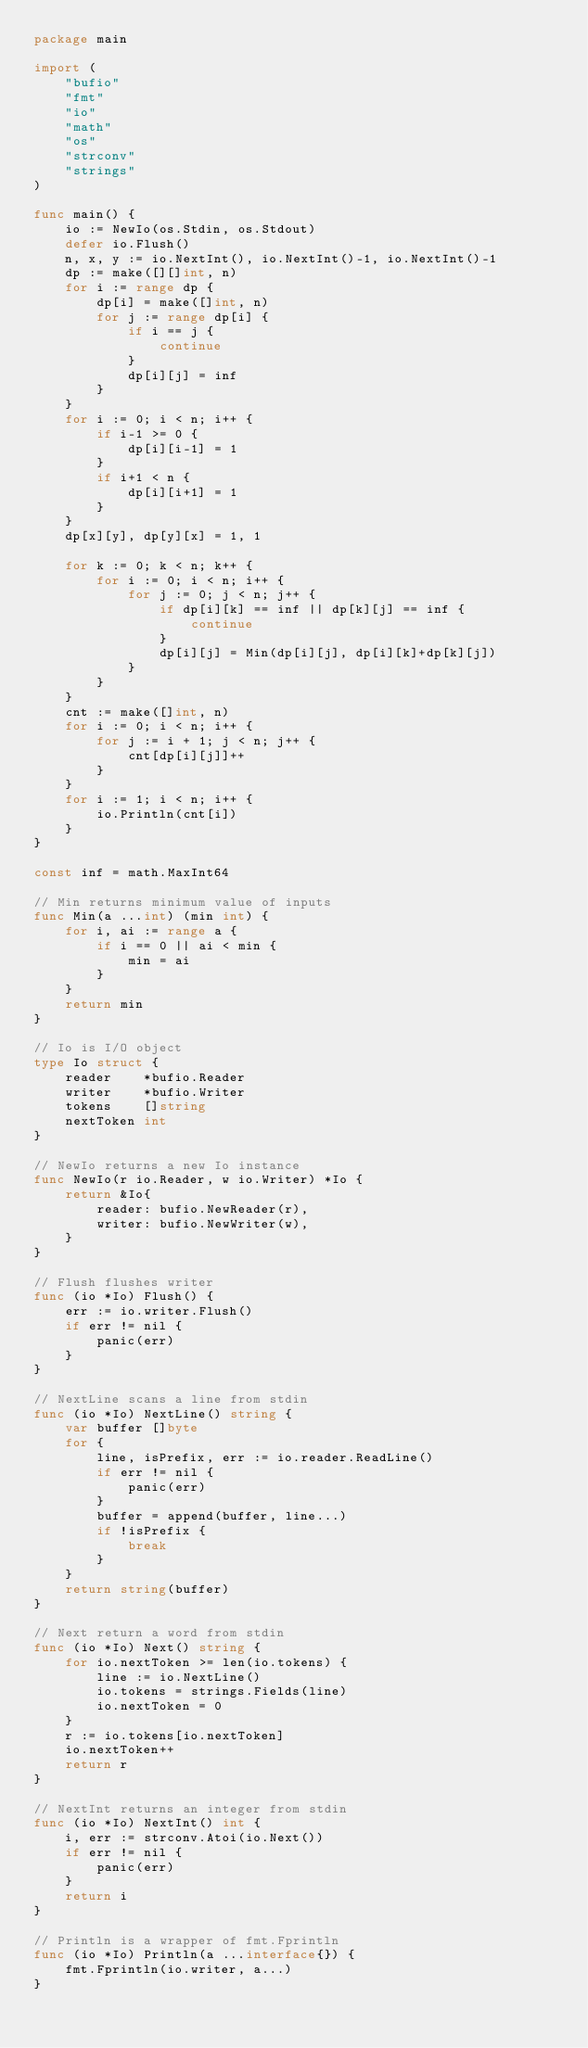Convert code to text. <code><loc_0><loc_0><loc_500><loc_500><_Go_>package main

import (
	"bufio"
	"fmt"
	"io"
	"math"
	"os"
	"strconv"
	"strings"
)

func main() {
	io := NewIo(os.Stdin, os.Stdout)
	defer io.Flush()
	n, x, y := io.NextInt(), io.NextInt()-1, io.NextInt()-1
	dp := make([][]int, n)
	for i := range dp {
		dp[i] = make([]int, n)
		for j := range dp[i] {
			if i == j {
				continue
			}
			dp[i][j] = inf
		}
	}
	for i := 0; i < n; i++ {
		if i-1 >= 0 {
			dp[i][i-1] = 1
		}
		if i+1 < n {
			dp[i][i+1] = 1
		}
	}
	dp[x][y], dp[y][x] = 1, 1

	for k := 0; k < n; k++ {
		for i := 0; i < n; i++ {
			for j := 0; j < n; j++ {
				if dp[i][k] == inf || dp[k][j] == inf {
					continue
				}
				dp[i][j] = Min(dp[i][j], dp[i][k]+dp[k][j])
			}
		}
	}
	cnt := make([]int, n)
	for i := 0; i < n; i++ {
		for j := i + 1; j < n; j++ {
			cnt[dp[i][j]]++
		}
	}
	for i := 1; i < n; i++ {
		io.Println(cnt[i])
	}
}

const inf = math.MaxInt64

// Min returns minimum value of inputs
func Min(a ...int) (min int) {
	for i, ai := range a {
		if i == 0 || ai < min {
			min = ai
		}
	}
	return min
}

// Io is I/O object
type Io struct {
	reader    *bufio.Reader
	writer    *bufio.Writer
	tokens    []string
	nextToken int
}

// NewIo returns a new Io instance
func NewIo(r io.Reader, w io.Writer) *Io {
	return &Io{
		reader: bufio.NewReader(r),
		writer: bufio.NewWriter(w),
	}
}

// Flush flushes writer
func (io *Io) Flush() {
	err := io.writer.Flush()
	if err != nil {
		panic(err)
	}
}

// NextLine scans a line from stdin
func (io *Io) NextLine() string {
	var buffer []byte
	for {
		line, isPrefix, err := io.reader.ReadLine()
		if err != nil {
			panic(err)
		}
		buffer = append(buffer, line...)
		if !isPrefix {
			break
		}
	}
	return string(buffer)
}

// Next return a word from stdin
func (io *Io) Next() string {
	for io.nextToken >= len(io.tokens) {
		line := io.NextLine()
		io.tokens = strings.Fields(line)
		io.nextToken = 0
	}
	r := io.tokens[io.nextToken]
	io.nextToken++
	return r
}

// NextInt returns an integer from stdin
func (io *Io) NextInt() int {
	i, err := strconv.Atoi(io.Next())
	if err != nil {
		panic(err)
	}
	return i
}

// Println is a wrapper of fmt.Fprintln
func (io *Io) Println(a ...interface{}) {
	fmt.Fprintln(io.writer, a...)
}
</code> 